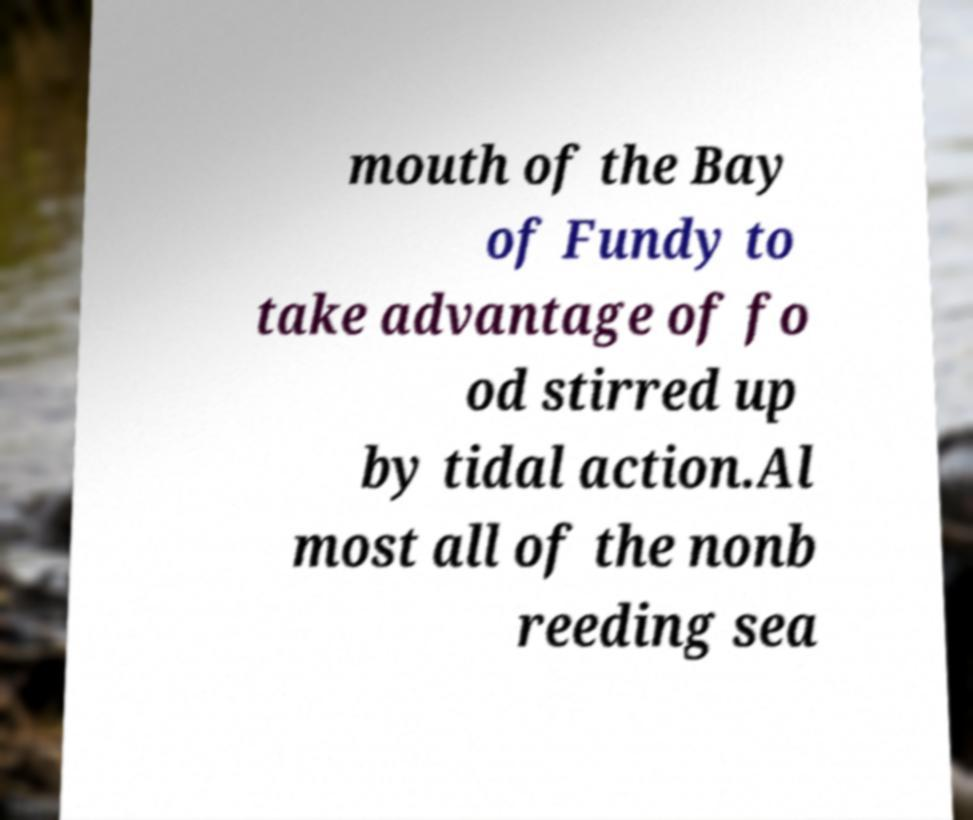Can you read and provide the text displayed in the image?This photo seems to have some interesting text. Can you extract and type it out for me? mouth of the Bay of Fundy to take advantage of fo od stirred up by tidal action.Al most all of the nonb reeding sea 